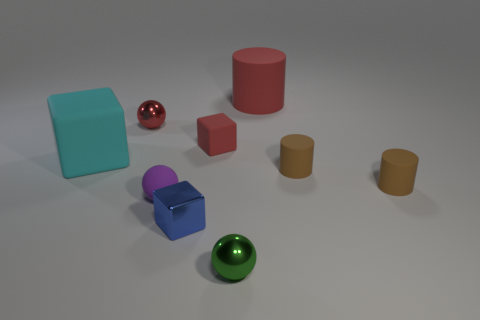Are there any red objects on the left side of the small blue metal object?
Give a very brief answer. Yes. There is a rubber thing that is behind the tiny red shiny thing; is there a tiny thing behind it?
Keep it short and to the point. No. Are there an equal number of small metallic spheres that are behind the large cyan object and large rubber cylinders behind the big rubber cylinder?
Give a very brief answer. No. There is a sphere that is made of the same material as the red cylinder; what color is it?
Your answer should be compact. Purple. Is there a big blue sphere made of the same material as the cyan block?
Offer a very short reply. No. How many objects are small green objects or red matte objects?
Your response must be concise. 3. Is the material of the tiny blue thing the same as the small sphere that is in front of the small purple rubber sphere?
Your answer should be very brief. Yes. There is a red rubber object that is left of the big red matte object; what size is it?
Provide a succinct answer. Small. Are there fewer cubes than blue metal blocks?
Offer a very short reply. No. Are there any big objects that have the same color as the matte ball?
Offer a terse response. No. 